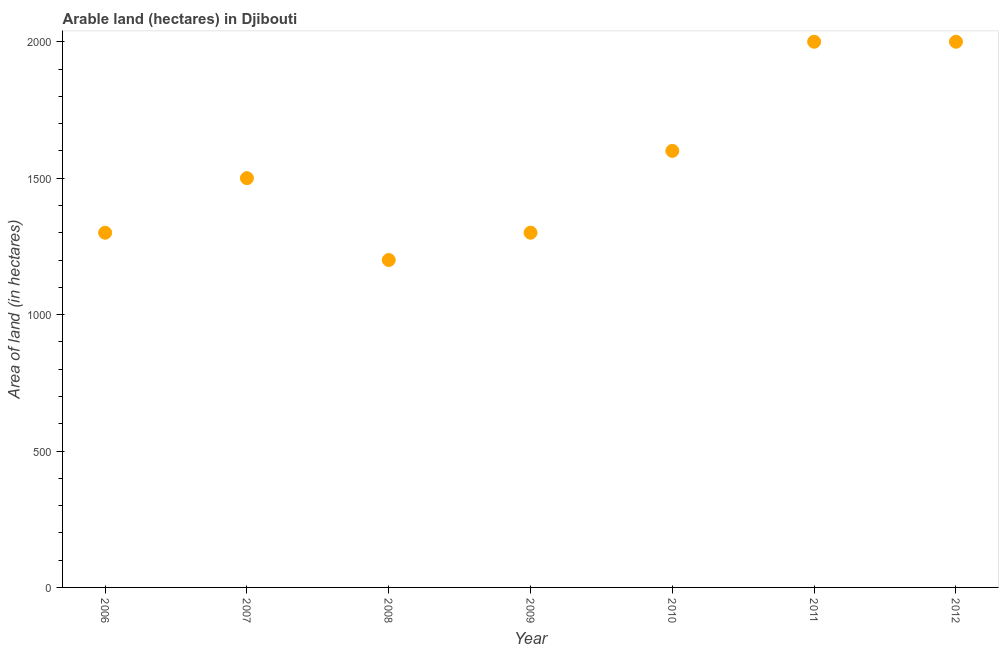What is the area of land in 2007?
Offer a very short reply. 1500. Across all years, what is the maximum area of land?
Provide a succinct answer. 2000. Across all years, what is the minimum area of land?
Give a very brief answer. 1200. In which year was the area of land minimum?
Offer a terse response. 2008. What is the sum of the area of land?
Keep it short and to the point. 1.09e+04. What is the difference between the area of land in 2006 and 2008?
Make the answer very short. 100. What is the average area of land per year?
Offer a terse response. 1557.14. What is the median area of land?
Offer a terse response. 1500. In how many years, is the area of land greater than 1300 hectares?
Offer a terse response. 4. Is the area of land in 2011 less than that in 2012?
Provide a succinct answer. No. Is the difference between the area of land in 2010 and 2012 greater than the difference between any two years?
Your response must be concise. No. What is the difference between the highest and the lowest area of land?
Provide a short and direct response. 800. How many years are there in the graph?
Your answer should be compact. 7. Are the values on the major ticks of Y-axis written in scientific E-notation?
Provide a succinct answer. No. Does the graph contain any zero values?
Ensure brevity in your answer.  No. Does the graph contain grids?
Your response must be concise. No. What is the title of the graph?
Provide a succinct answer. Arable land (hectares) in Djibouti. What is the label or title of the Y-axis?
Your response must be concise. Area of land (in hectares). What is the Area of land (in hectares) in 2006?
Your answer should be very brief. 1300. What is the Area of land (in hectares) in 2007?
Your answer should be compact. 1500. What is the Area of land (in hectares) in 2008?
Ensure brevity in your answer.  1200. What is the Area of land (in hectares) in 2009?
Your answer should be very brief. 1300. What is the Area of land (in hectares) in 2010?
Your answer should be compact. 1600. What is the Area of land (in hectares) in 2011?
Provide a short and direct response. 2000. What is the Area of land (in hectares) in 2012?
Your answer should be very brief. 2000. What is the difference between the Area of land (in hectares) in 2006 and 2007?
Give a very brief answer. -200. What is the difference between the Area of land (in hectares) in 2006 and 2008?
Your answer should be very brief. 100. What is the difference between the Area of land (in hectares) in 2006 and 2010?
Your answer should be compact. -300. What is the difference between the Area of land (in hectares) in 2006 and 2011?
Your answer should be compact. -700. What is the difference between the Area of land (in hectares) in 2006 and 2012?
Offer a very short reply. -700. What is the difference between the Area of land (in hectares) in 2007 and 2008?
Offer a very short reply. 300. What is the difference between the Area of land (in hectares) in 2007 and 2010?
Ensure brevity in your answer.  -100. What is the difference between the Area of land (in hectares) in 2007 and 2011?
Provide a succinct answer. -500. What is the difference between the Area of land (in hectares) in 2007 and 2012?
Provide a succinct answer. -500. What is the difference between the Area of land (in hectares) in 2008 and 2009?
Make the answer very short. -100. What is the difference between the Area of land (in hectares) in 2008 and 2010?
Provide a succinct answer. -400. What is the difference between the Area of land (in hectares) in 2008 and 2011?
Ensure brevity in your answer.  -800. What is the difference between the Area of land (in hectares) in 2008 and 2012?
Ensure brevity in your answer.  -800. What is the difference between the Area of land (in hectares) in 2009 and 2010?
Keep it short and to the point. -300. What is the difference between the Area of land (in hectares) in 2009 and 2011?
Offer a very short reply. -700. What is the difference between the Area of land (in hectares) in 2009 and 2012?
Offer a terse response. -700. What is the difference between the Area of land (in hectares) in 2010 and 2011?
Your answer should be compact. -400. What is the difference between the Area of land (in hectares) in 2010 and 2012?
Give a very brief answer. -400. What is the difference between the Area of land (in hectares) in 2011 and 2012?
Offer a very short reply. 0. What is the ratio of the Area of land (in hectares) in 2006 to that in 2007?
Your answer should be compact. 0.87. What is the ratio of the Area of land (in hectares) in 2006 to that in 2008?
Your answer should be very brief. 1.08. What is the ratio of the Area of land (in hectares) in 2006 to that in 2009?
Make the answer very short. 1. What is the ratio of the Area of land (in hectares) in 2006 to that in 2010?
Provide a succinct answer. 0.81. What is the ratio of the Area of land (in hectares) in 2006 to that in 2011?
Your answer should be compact. 0.65. What is the ratio of the Area of land (in hectares) in 2006 to that in 2012?
Make the answer very short. 0.65. What is the ratio of the Area of land (in hectares) in 2007 to that in 2008?
Give a very brief answer. 1.25. What is the ratio of the Area of land (in hectares) in 2007 to that in 2009?
Make the answer very short. 1.15. What is the ratio of the Area of land (in hectares) in 2007 to that in 2010?
Provide a short and direct response. 0.94. What is the ratio of the Area of land (in hectares) in 2007 to that in 2011?
Ensure brevity in your answer.  0.75. What is the ratio of the Area of land (in hectares) in 2007 to that in 2012?
Your answer should be very brief. 0.75. What is the ratio of the Area of land (in hectares) in 2008 to that in 2009?
Offer a very short reply. 0.92. What is the ratio of the Area of land (in hectares) in 2009 to that in 2010?
Provide a short and direct response. 0.81. What is the ratio of the Area of land (in hectares) in 2009 to that in 2011?
Ensure brevity in your answer.  0.65. What is the ratio of the Area of land (in hectares) in 2009 to that in 2012?
Keep it short and to the point. 0.65. What is the ratio of the Area of land (in hectares) in 2010 to that in 2011?
Offer a terse response. 0.8. What is the ratio of the Area of land (in hectares) in 2010 to that in 2012?
Provide a short and direct response. 0.8. What is the ratio of the Area of land (in hectares) in 2011 to that in 2012?
Provide a succinct answer. 1. 